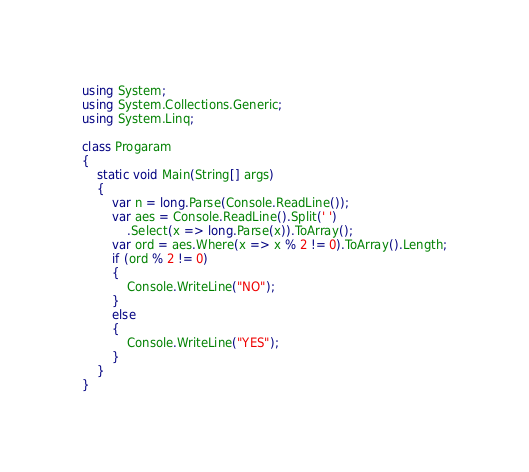<code> <loc_0><loc_0><loc_500><loc_500><_C#_>using System;
using System.Collections.Generic;
using System.Linq;

class Progaram
{
    static void Main(String[] args)
    {
        var n = long.Parse(Console.ReadLine());
        var aes = Console.ReadLine().Split(' ')
            .Select(x => long.Parse(x)).ToArray();
        var ord = aes.Where(x => x % 2 != 0).ToArray().Length;
        if (ord % 2 != 0)
        {
            Console.WriteLine("NO");
        }
        else
        {
            Console.WriteLine("YES");
        }
    }
}
</code> 